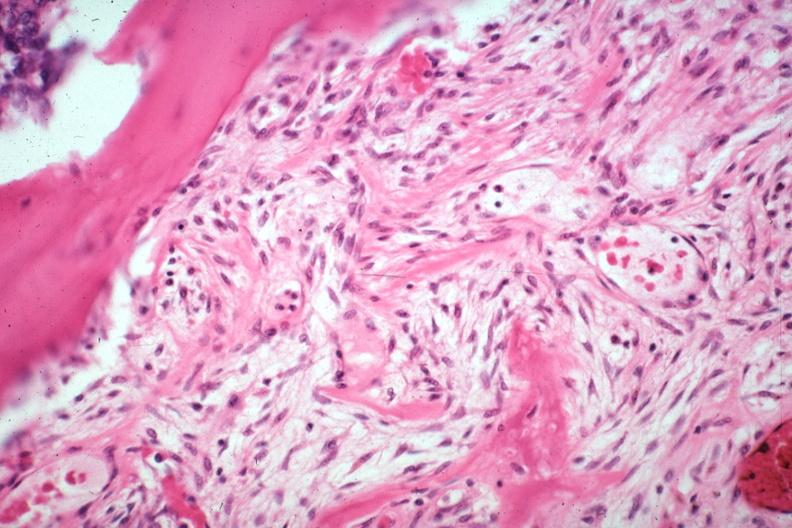what induced new bone formation large myofibroblastic osteoblastic cells in stroma with focus of osteoid case of 8 year survival breast intraductal papillary adenocarcinoma?
Answer the question using a single word or phrase. Tumor 